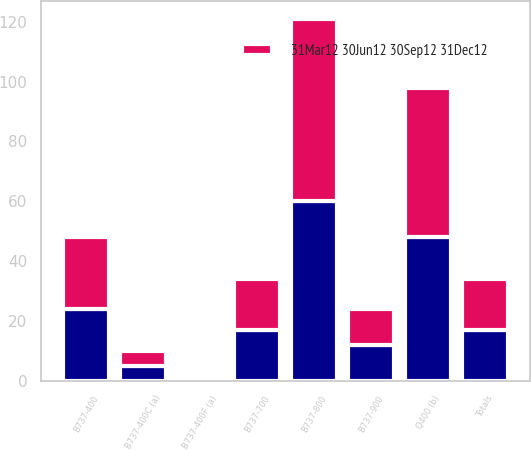Convert chart. <chart><loc_0><loc_0><loc_500><loc_500><stacked_bar_chart><ecel><fcel>B737-400<fcel>B737-400F (a)<fcel>B737-400C (a)<fcel>B737-700<fcel>B737-800<fcel>B737-900<fcel>Q400 (b)<fcel>Totals<nl><fcel>nan<fcel>24<fcel>1<fcel>5<fcel>17<fcel>60<fcel>12<fcel>48<fcel>17<nl><fcel>31Mar12 30Jun12 30Sep12 31Dec12<fcel>24<fcel>1<fcel>5<fcel>17<fcel>61<fcel>12<fcel>50<fcel>17<nl></chart> 